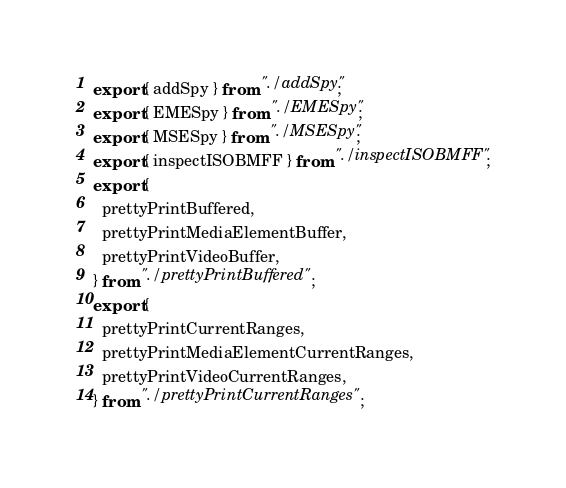Convert code to text. <code><loc_0><loc_0><loc_500><loc_500><_JavaScript_>export { addSpy } from "./addSpy";
export { EMESpy } from "./EMESpy";
export { MSESpy } from "./MSESpy";
export { inspectISOBMFF } from "./inspectISOBMFF";
export {
  prettyPrintBuffered,
  prettyPrintMediaElementBuffer,
  prettyPrintVideoBuffer,
} from "./prettyPrintBuffered";
export {
  prettyPrintCurrentRanges,
  prettyPrintMediaElementCurrentRanges,
  prettyPrintVideoCurrentRanges,
} from "./prettyPrintCurrentRanges";
</code> 